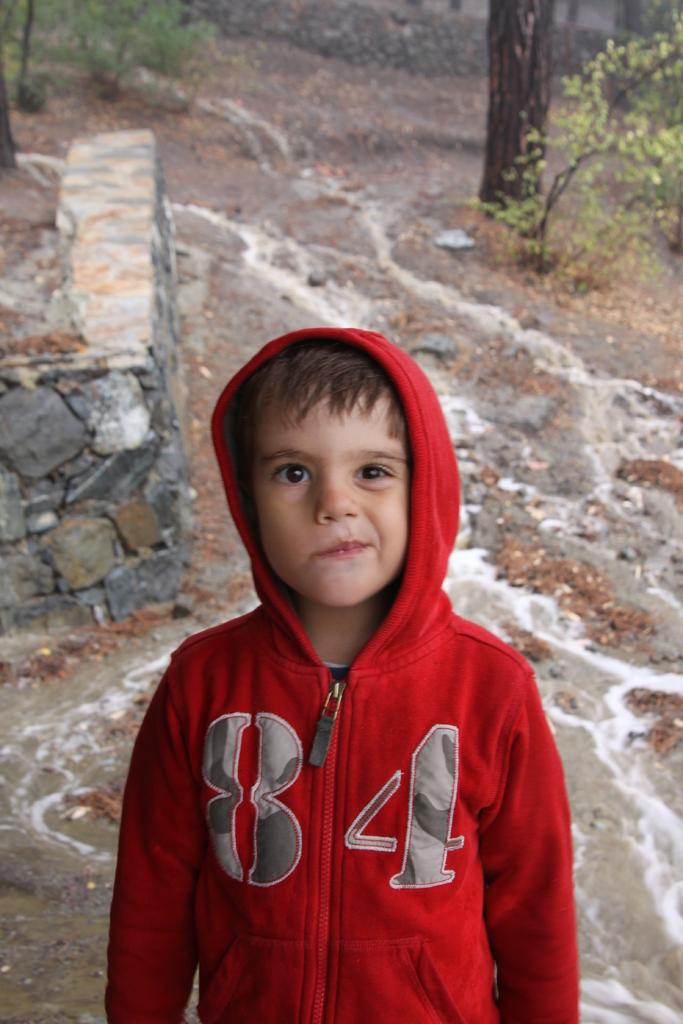<image>
Create a compact narrative representing the image presented. A boy with the number 84 on a red jacket 